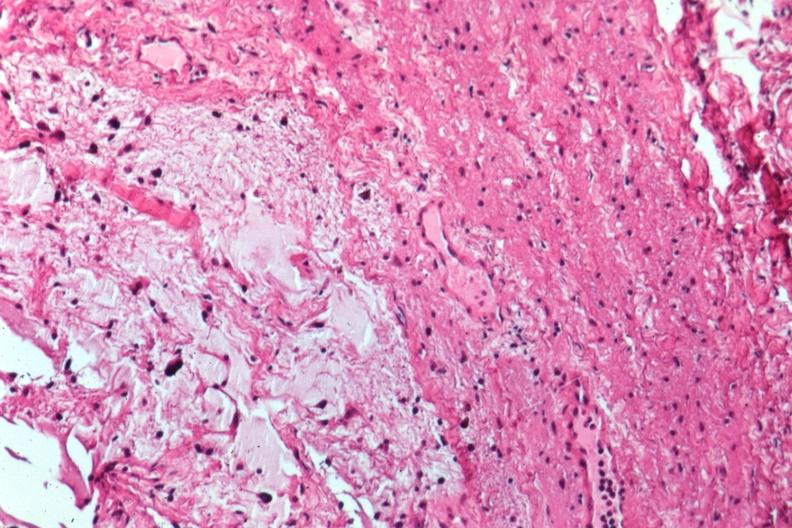s cytomegaly present?
Answer the question using a single word or phrase. No 